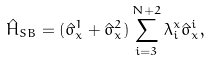<formula> <loc_0><loc_0><loc_500><loc_500>\hat { H } _ { S B } = ( \hat { \sigma } _ { x } ^ { 1 } + \hat { \sigma } _ { x } ^ { 2 } ) \sum _ { i = 3 } ^ { N + 2 } \lambda _ { i } ^ { x } \hat { \sigma } _ { x } ^ { i } ,</formula> 